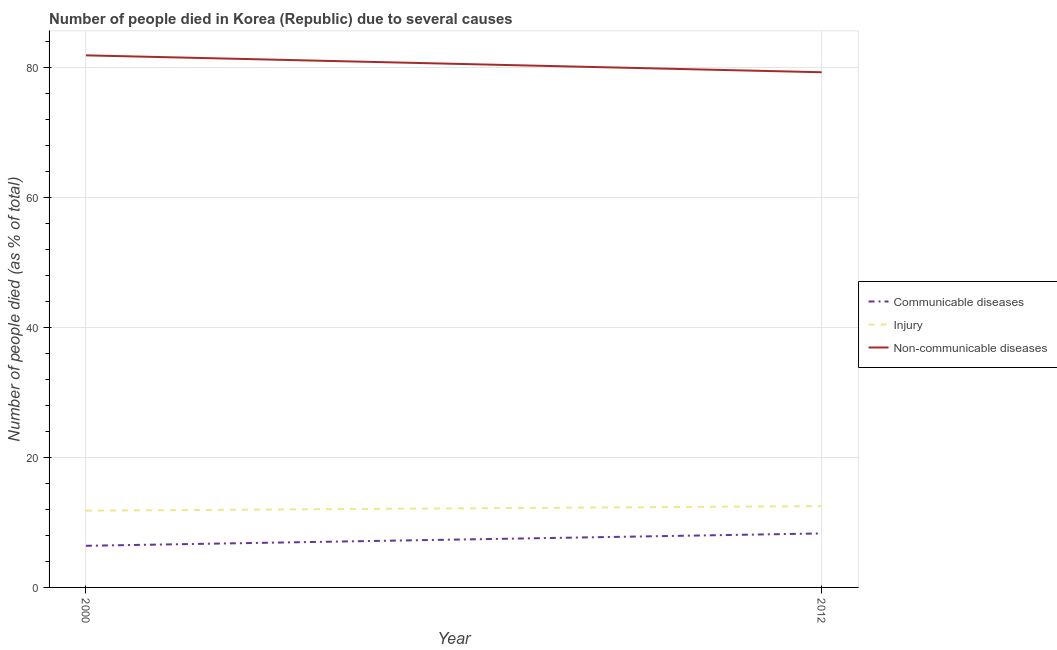Does the line corresponding to number of people who died of injury intersect with the line corresponding to number of people who dies of non-communicable diseases?
Provide a succinct answer. No. Is the number of lines equal to the number of legend labels?
Provide a short and direct response. Yes. What is the number of people who dies of non-communicable diseases in 2000?
Offer a very short reply. 81.8. Across all years, what is the maximum number of people who died of communicable diseases?
Provide a short and direct response. 8.3. Across all years, what is the minimum number of people who dies of non-communicable diseases?
Ensure brevity in your answer.  79.2. In which year was the number of people who died of communicable diseases maximum?
Your response must be concise. 2012. What is the total number of people who died of communicable diseases in the graph?
Offer a very short reply. 14.7. What is the difference between the number of people who dies of non-communicable diseases in 2000 and that in 2012?
Offer a very short reply. 2.6. What is the average number of people who dies of non-communicable diseases per year?
Your answer should be very brief. 80.5. In the year 2000, what is the difference between the number of people who dies of non-communicable diseases and number of people who died of communicable diseases?
Ensure brevity in your answer.  75.4. In how many years, is the number of people who died of injury greater than 44 %?
Your answer should be very brief. 0. What is the ratio of the number of people who dies of non-communicable diseases in 2000 to that in 2012?
Your answer should be very brief. 1.03. In how many years, is the number of people who dies of non-communicable diseases greater than the average number of people who dies of non-communicable diseases taken over all years?
Offer a terse response. 1. Does the number of people who dies of non-communicable diseases monotonically increase over the years?
Offer a very short reply. No. Is the number of people who dies of non-communicable diseases strictly greater than the number of people who died of communicable diseases over the years?
Make the answer very short. Yes. How many lines are there?
Your response must be concise. 3. Where does the legend appear in the graph?
Ensure brevity in your answer.  Center right. How many legend labels are there?
Provide a short and direct response. 3. What is the title of the graph?
Provide a short and direct response. Number of people died in Korea (Republic) due to several causes. What is the label or title of the Y-axis?
Your response must be concise. Number of people died (as % of total). What is the Number of people died (as % of total) in Non-communicable diseases in 2000?
Your answer should be very brief. 81.8. What is the Number of people died (as % of total) in Communicable diseases in 2012?
Make the answer very short. 8.3. What is the Number of people died (as % of total) of Injury in 2012?
Your answer should be very brief. 12.5. What is the Number of people died (as % of total) of Non-communicable diseases in 2012?
Your answer should be very brief. 79.2. Across all years, what is the maximum Number of people died (as % of total) in Injury?
Offer a very short reply. 12.5. Across all years, what is the maximum Number of people died (as % of total) in Non-communicable diseases?
Your response must be concise. 81.8. Across all years, what is the minimum Number of people died (as % of total) of Communicable diseases?
Your response must be concise. 6.4. Across all years, what is the minimum Number of people died (as % of total) in Non-communicable diseases?
Offer a terse response. 79.2. What is the total Number of people died (as % of total) of Communicable diseases in the graph?
Offer a very short reply. 14.7. What is the total Number of people died (as % of total) of Injury in the graph?
Your answer should be very brief. 24.3. What is the total Number of people died (as % of total) in Non-communicable diseases in the graph?
Offer a terse response. 161. What is the difference between the Number of people died (as % of total) of Injury in 2000 and that in 2012?
Make the answer very short. -0.7. What is the difference between the Number of people died (as % of total) in Communicable diseases in 2000 and the Number of people died (as % of total) in Non-communicable diseases in 2012?
Your answer should be compact. -72.8. What is the difference between the Number of people died (as % of total) in Injury in 2000 and the Number of people died (as % of total) in Non-communicable diseases in 2012?
Give a very brief answer. -67.4. What is the average Number of people died (as % of total) in Communicable diseases per year?
Ensure brevity in your answer.  7.35. What is the average Number of people died (as % of total) of Injury per year?
Make the answer very short. 12.15. What is the average Number of people died (as % of total) of Non-communicable diseases per year?
Give a very brief answer. 80.5. In the year 2000, what is the difference between the Number of people died (as % of total) in Communicable diseases and Number of people died (as % of total) in Injury?
Provide a succinct answer. -5.4. In the year 2000, what is the difference between the Number of people died (as % of total) in Communicable diseases and Number of people died (as % of total) in Non-communicable diseases?
Your answer should be compact. -75.4. In the year 2000, what is the difference between the Number of people died (as % of total) in Injury and Number of people died (as % of total) in Non-communicable diseases?
Ensure brevity in your answer.  -70. In the year 2012, what is the difference between the Number of people died (as % of total) of Communicable diseases and Number of people died (as % of total) of Non-communicable diseases?
Your answer should be very brief. -70.9. In the year 2012, what is the difference between the Number of people died (as % of total) of Injury and Number of people died (as % of total) of Non-communicable diseases?
Keep it short and to the point. -66.7. What is the ratio of the Number of people died (as % of total) of Communicable diseases in 2000 to that in 2012?
Your response must be concise. 0.77. What is the ratio of the Number of people died (as % of total) in Injury in 2000 to that in 2012?
Offer a very short reply. 0.94. What is the ratio of the Number of people died (as % of total) of Non-communicable diseases in 2000 to that in 2012?
Keep it short and to the point. 1.03. What is the difference between the highest and the lowest Number of people died (as % of total) in Injury?
Your response must be concise. 0.7. 